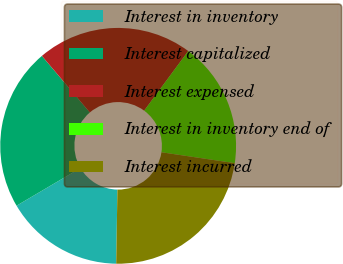Convert chart to OTSL. <chart><loc_0><loc_0><loc_500><loc_500><pie_chart><fcel>Interest in inventory<fcel>Interest capitalized<fcel>Interest expensed<fcel>Interest in inventory end of<fcel>Interest incurred<nl><fcel>16.26%<fcel>22.28%<fcel>21.33%<fcel>17.21%<fcel>22.92%<nl></chart> 